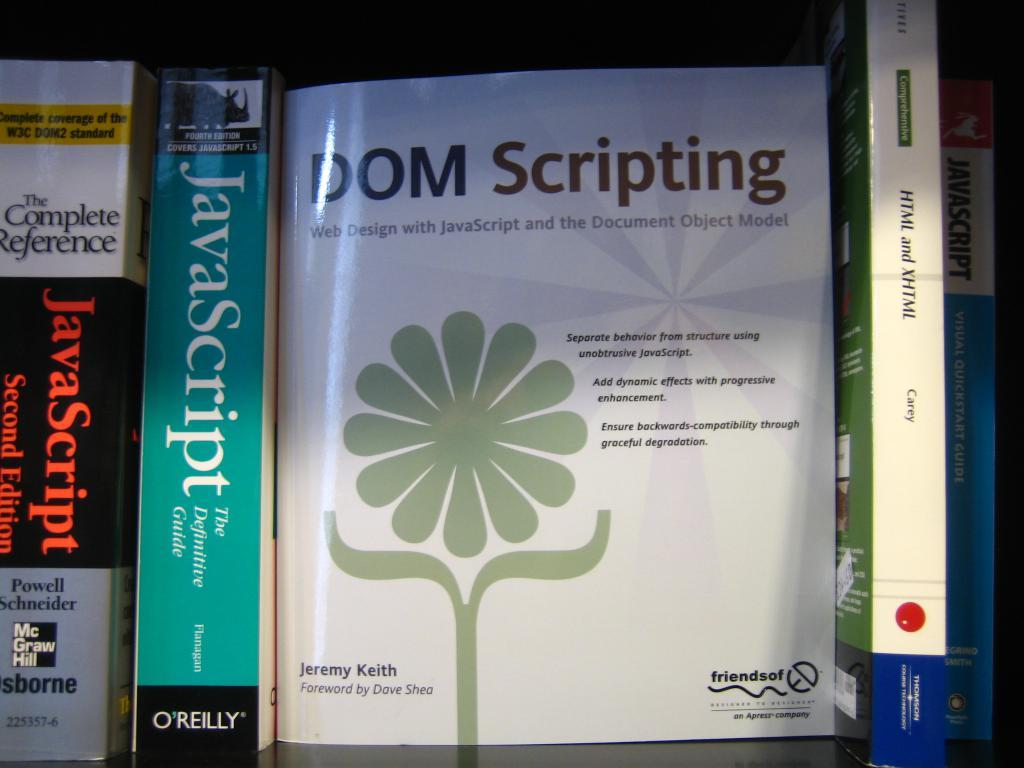<image>
Create a compact narrative representing the image presented. A book about DOM Scripting sits next to a book about Java Script 